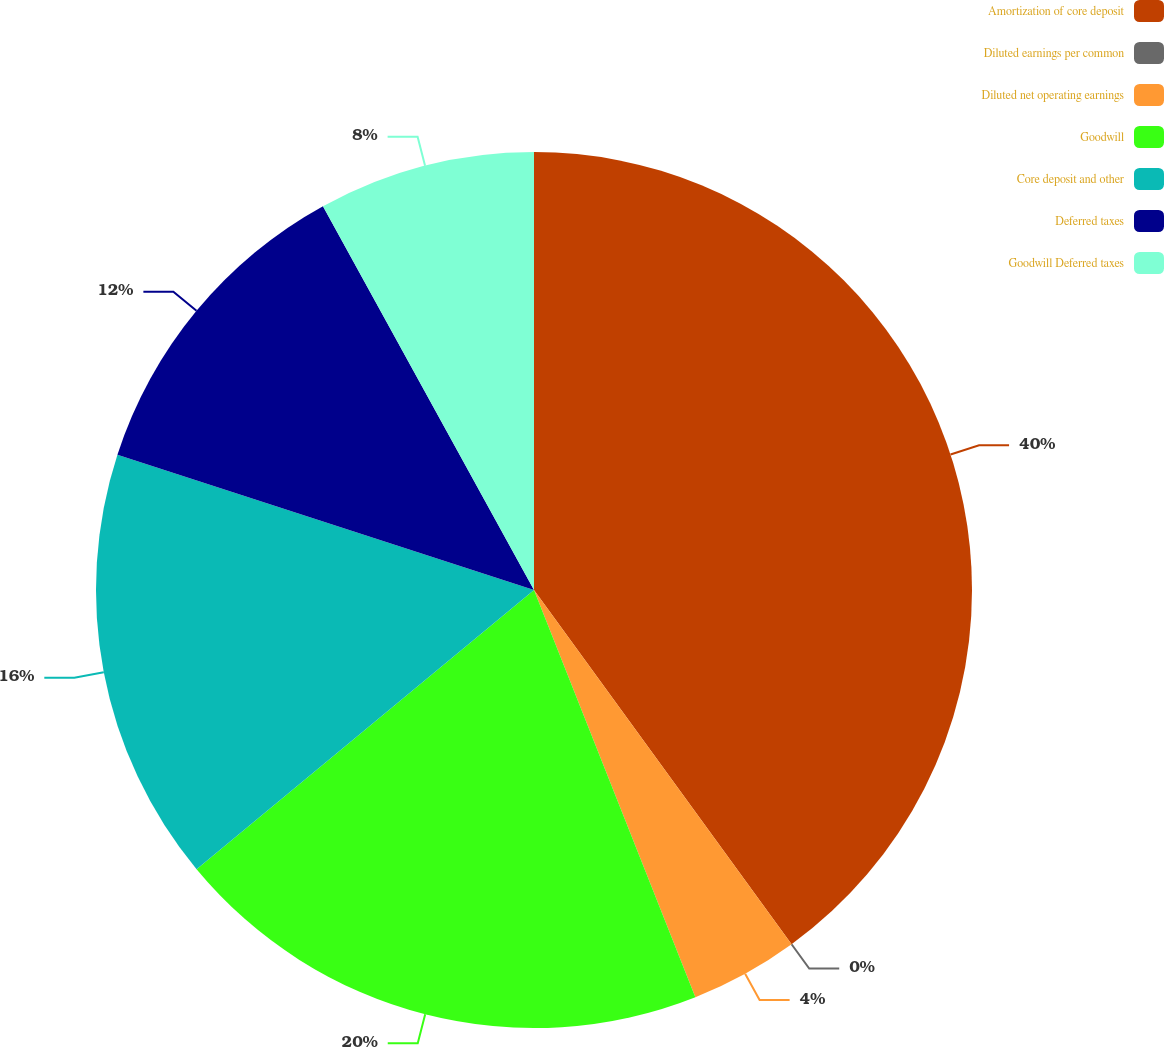Convert chart. <chart><loc_0><loc_0><loc_500><loc_500><pie_chart><fcel>Amortization of core deposit<fcel>Diluted earnings per common<fcel>Diluted net operating earnings<fcel>Goodwill<fcel>Core deposit and other<fcel>Deferred taxes<fcel>Goodwill Deferred taxes<nl><fcel>39.99%<fcel>0.0%<fcel>4.0%<fcel>20.0%<fcel>16.0%<fcel>12.0%<fcel>8.0%<nl></chart> 